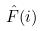<formula> <loc_0><loc_0><loc_500><loc_500>\hat { F } ( i )</formula> 